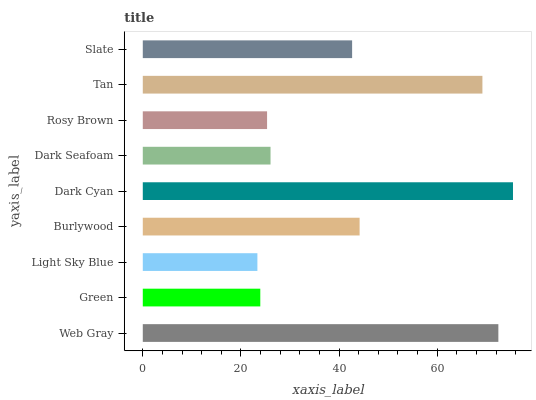Is Light Sky Blue the minimum?
Answer yes or no. Yes. Is Dark Cyan the maximum?
Answer yes or no. Yes. Is Green the minimum?
Answer yes or no. No. Is Green the maximum?
Answer yes or no. No. Is Web Gray greater than Green?
Answer yes or no. Yes. Is Green less than Web Gray?
Answer yes or no. Yes. Is Green greater than Web Gray?
Answer yes or no. No. Is Web Gray less than Green?
Answer yes or no. No. Is Slate the high median?
Answer yes or no. Yes. Is Slate the low median?
Answer yes or no. Yes. Is Green the high median?
Answer yes or no. No. Is Tan the low median?
Answer yes or no. No. 